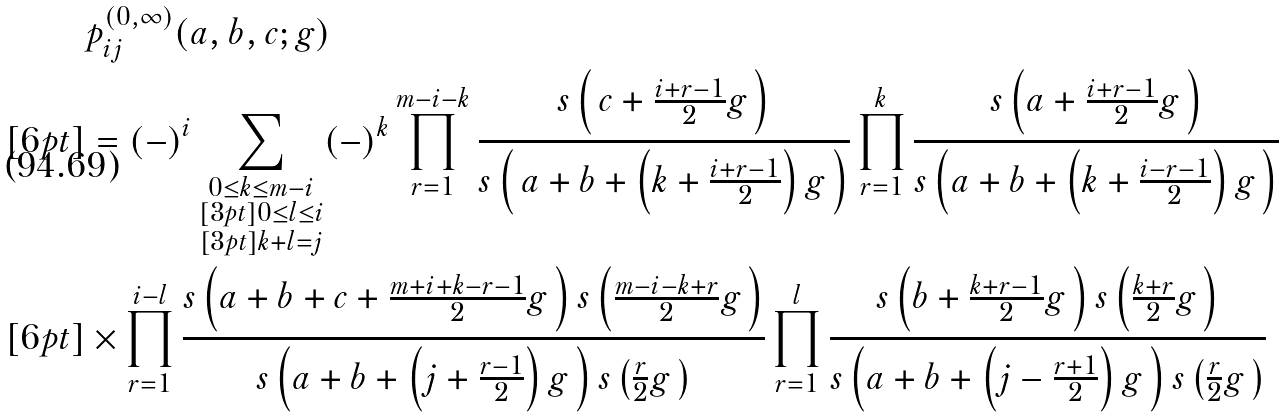Convert formula to latex. <formula><loc_0><loc_0><loc_500><loc_500>& p _ { i j } ^ { ( 0 , \infty ) } ( a , b , c ; g ) \\ [ 6 p t ] & = ( - ) ^ { i } \sum _ { \substack { 0 \leq k \leq m - i \\ [ 3 p t ] 0 \leq l \leq i \\ [ 3 p t ] k + l = j } } ( - ) ^ { k } \prod _ { r = 1 } ^ { m - i - k } \frac { s \left ( \, c + \frac { i + r - 1 } { 2 } g \, \right ) } { s \left ( \, a + b + \left ( k + \frac { i + r - 1 } { 2 } \right ) g \, \right ) } \prod _ { r = 1 } ^ { k } \frac { s \left ( a + \frac { i + r - 1 } { 2 } g \, \right ) } { s \left ( a + b + \left ( k + \frac { i - r - 1 } { 2 } \right ) g \, \right ) } \\ [ 6 p t ] & \times \prod _ { r = 1 } ^ { i - l } \frac { s \left ( a + b + c + \frac { m + i + k - r - 1 } { 2 } g \, \right ) s \left ( \frac { m - i - k + r } { 2 } g \, \right ) } { s \left ( a + b + \left ( j + \frac { r - 1 } { 2 } \right ) g \, \right ) s \left ( \frac { r } { 2 } g \, \right ) } \prod _ { r = 1 } ^ { l } \frac { s \left ( b + \frac { k + r - 1 } { 2 } g \, \right ) s \left ( \frac { k + r } { 2 } g \, \right ) } { s \left ( a + b + \left ( j - \frac { r + 1 } { 2 } \right ) g \, \right ) s \left ( \frac { r } { 2 } g \, \right ) }</formula> 